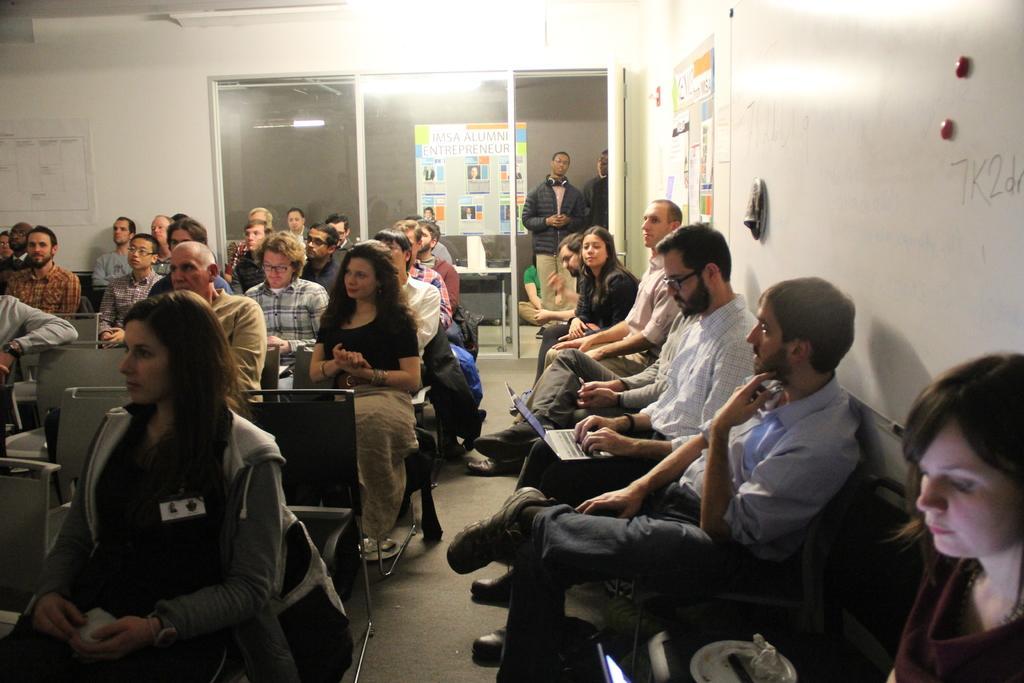In one or two sentences, can you explain what this image depicts? In this image we can see few people sitting on chairs in a room, some of them are working on laptops, there are few posts attached to the walls and in the background there is a glass door and a person is standing and wearing a headphone. 